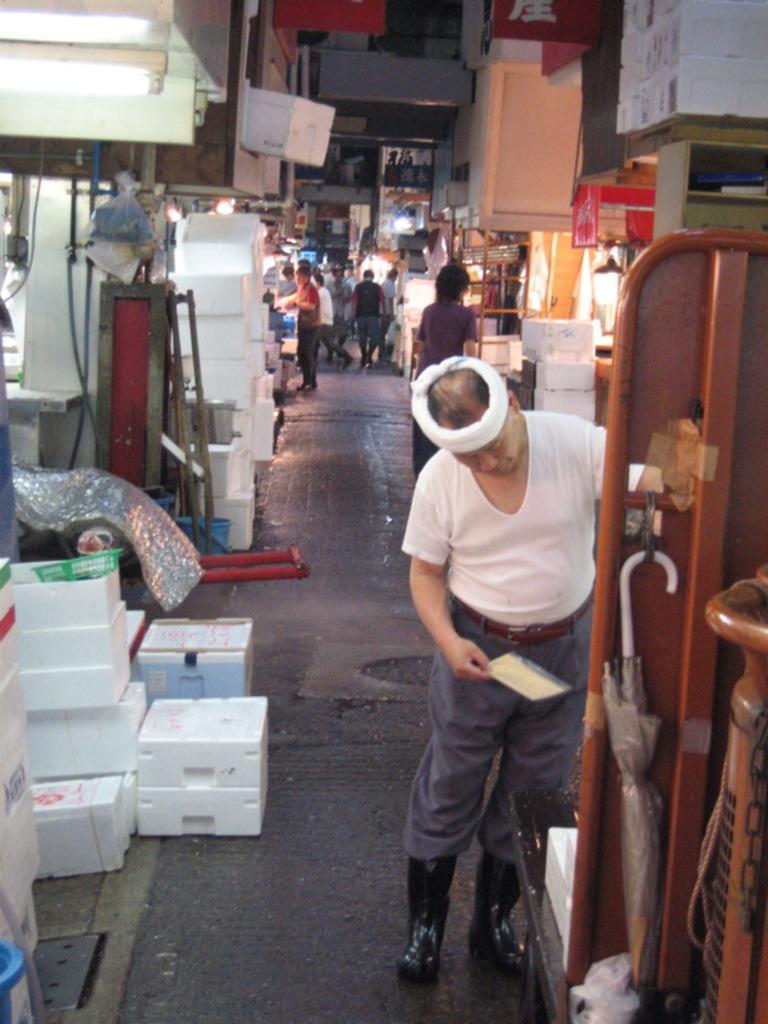How would you summarize this image in a sentence or two? In the foreground we can see a man standing on the floor and he is holding a sheet of paper in his right hand. Here we can see the wooden block on the right side. Here we can see an umbrella on the hook. In the background, we can see a few people walking on the road. Here we can see the retail stores. Here we can see the packed boxes on the left side. 